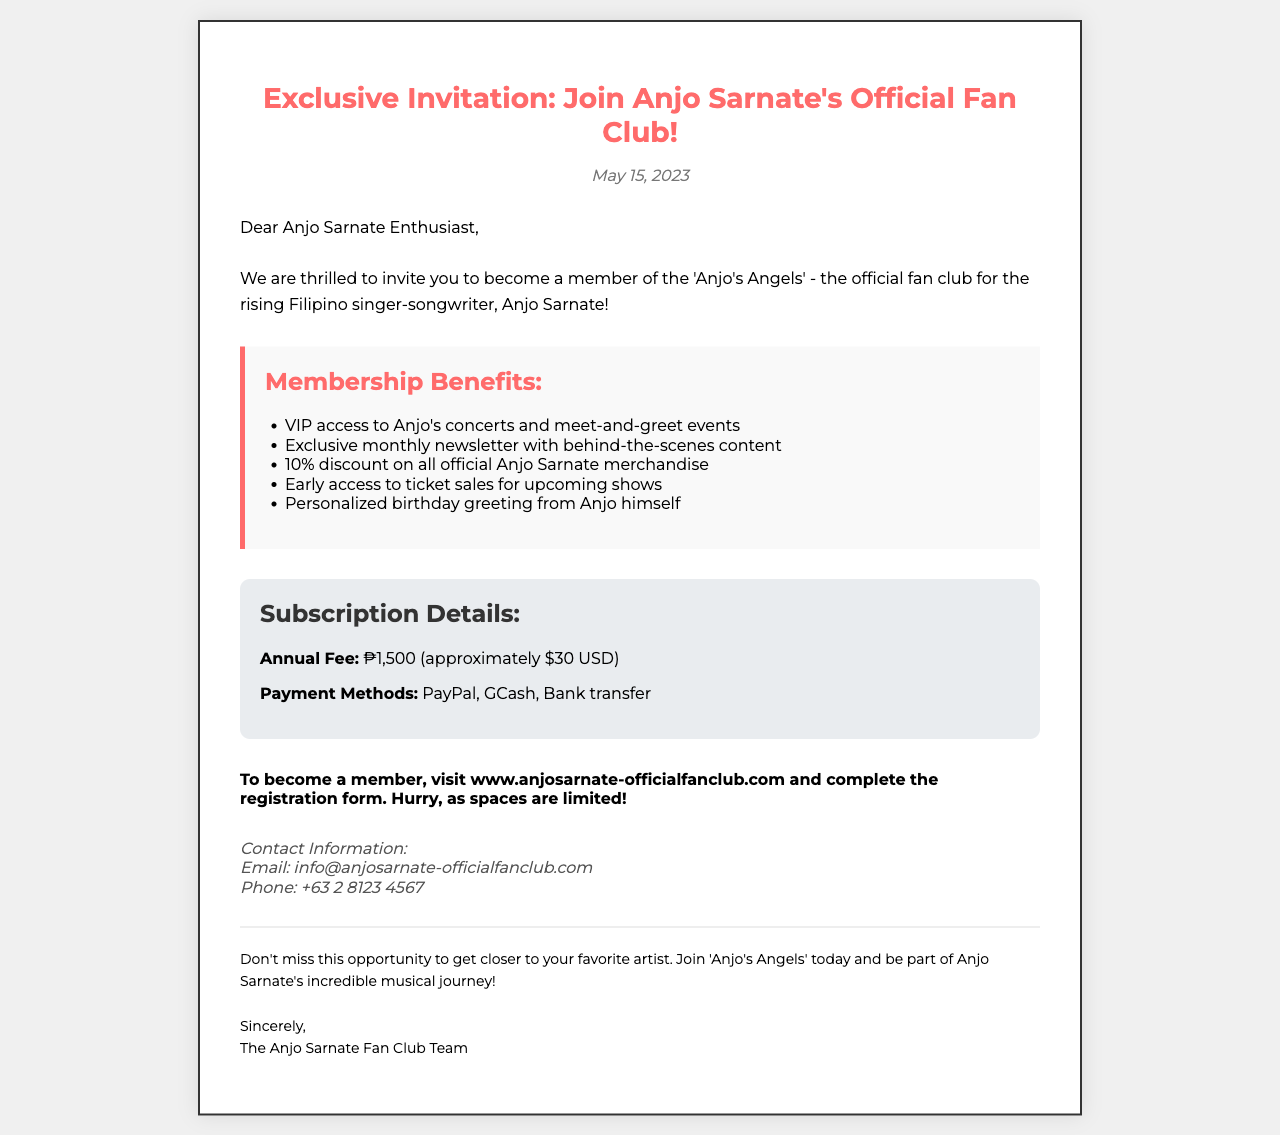What is the name of the fan club? The document states the name of the fan club as 'Anjo's Angels'.
Answer: 'Anjo's Angels' What is the annual subscription fee? The document lists the annual fee for membership as ₱1,500.
Answer: ₱1,500 What percentage discount do members receive on merchandise? The benefits section indicates that members receive a 10% discount on merchandise.
Answer: 10% What is the website to join the fan club? The document states that to become a member, one should visit www.anjosarnate-officialfanclub.com.
Answer: www.anjosarnate-officialfanclub.com What is one of the benefits of membership? The benefits list includes VIP access to Anjo's concerts and meet-and-greet events.
Answer: VIP access to concerts How can payment be made for membership? The document mentions several payment methods: PayPal, GCash, Bank transfer.
Answer: PayPal, GCash, Bank transfer What is the contact email for the fan club? The document provides the contact email as info@anjosarnate-officialfanclub.com.
Answer: info@anjosarnate-officialfanclub.com When was the invitation date? The date listed on the invitation is May 15, 2023.
Answer: May 15, 2023 What greeting do members receive from Anjo? It is stated that members receive a personalized birthday greeting from Anjo himself.
Answer: Personalized birthday greeting 